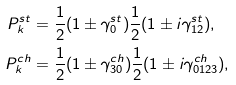Convert formula to latex. <formula><loc_0><loc_0><loc_500><loc_500>P _ { k } ^ { s t } & = \frac { 1 } { 2 } ( 1 \pm \gamma _ { 0 } ^ { s t } ) \frac { 1 } { 2 } ( 1 \pm i \gamma _ { 1 2 } ^ { s t } ) , \\ P _ { k } ^ { c h } & = \frac { 1 } { 2 } ( 1 \pm \gamma _ { 3 0 } ^ { c h } ) \frac { 1 } { 2 } ( 1 \pm i \gamma _ { 0 1 2 3 } ^ { c h } ) ,</formula> 